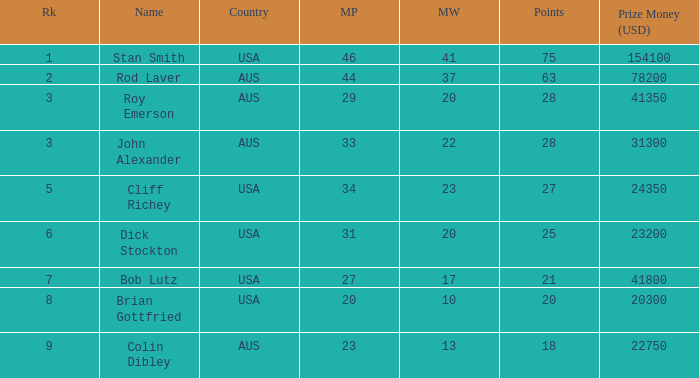How many matches did the player that played 23 matches win 13.0. 